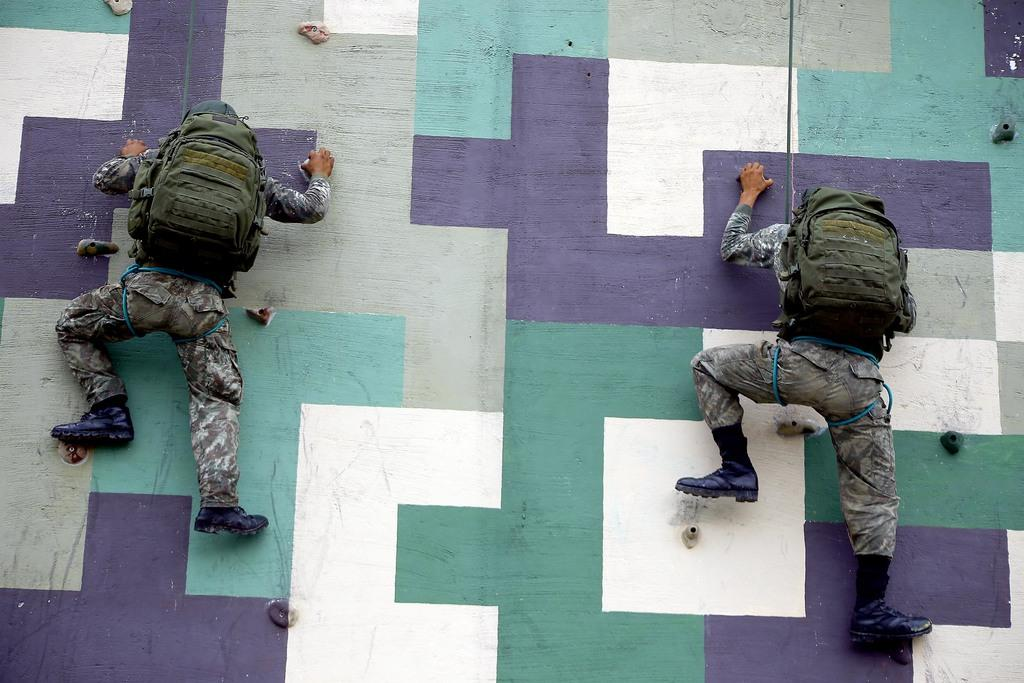How many people are in the image? There are two people in the image. What are the people wearing? The people are wearing military uniforms. What are the people carrying? The people are carrying bags. What activity are the people engaged in? The people are climbing a wall. Can you describe the colors of the wall? The wall has green, purple, white, and ash colors. What type of tray is being used to carry the coal in the image? There is no tray or coal present in the image. What kind of apparatus is being used by the people in the image? The people in the image are not using any specific apparatus; they are simply climbing a wall while wearing military uniforms and carrying bags. 